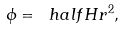Convert formula to latex. <formula><loc_0><loc_0><loc_500><loc_500>\phi = \ h a l f H r ^ { 2 } ,</formula> 